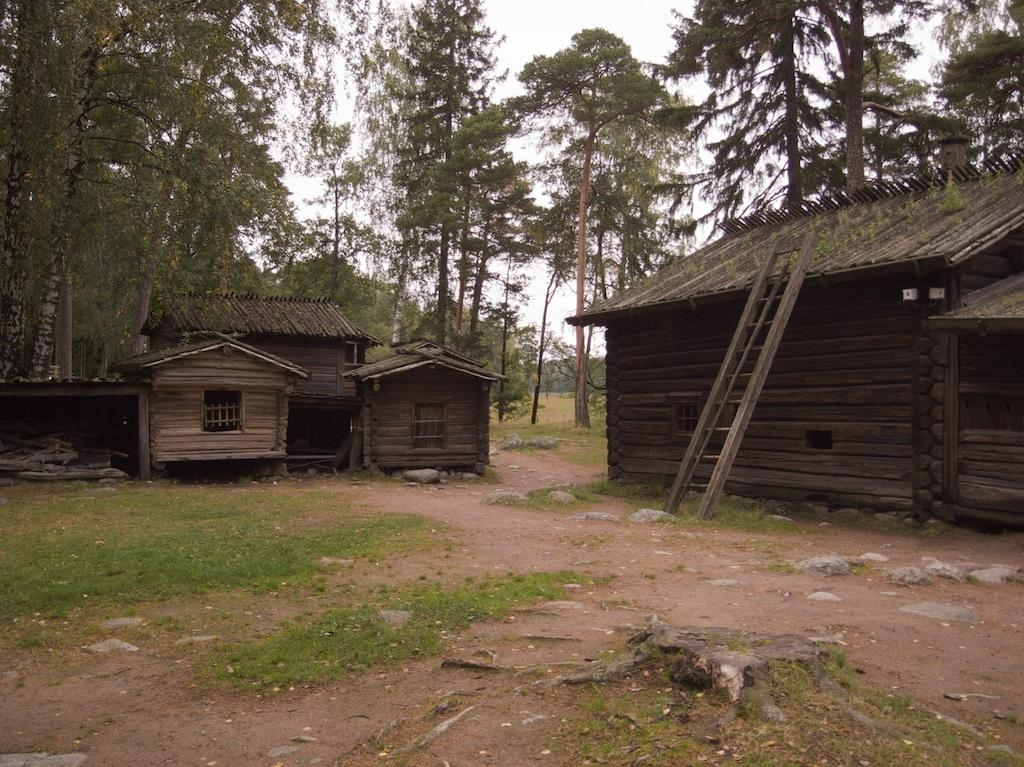What type of structures are present in the image? There are wooden huts in the image. What can be seen in the background of the image? There are trees in the background of the image. What type of hose is being used by the hen in the image? There is no hen or hose present in the image; it features wooden huts and trees in the background. 